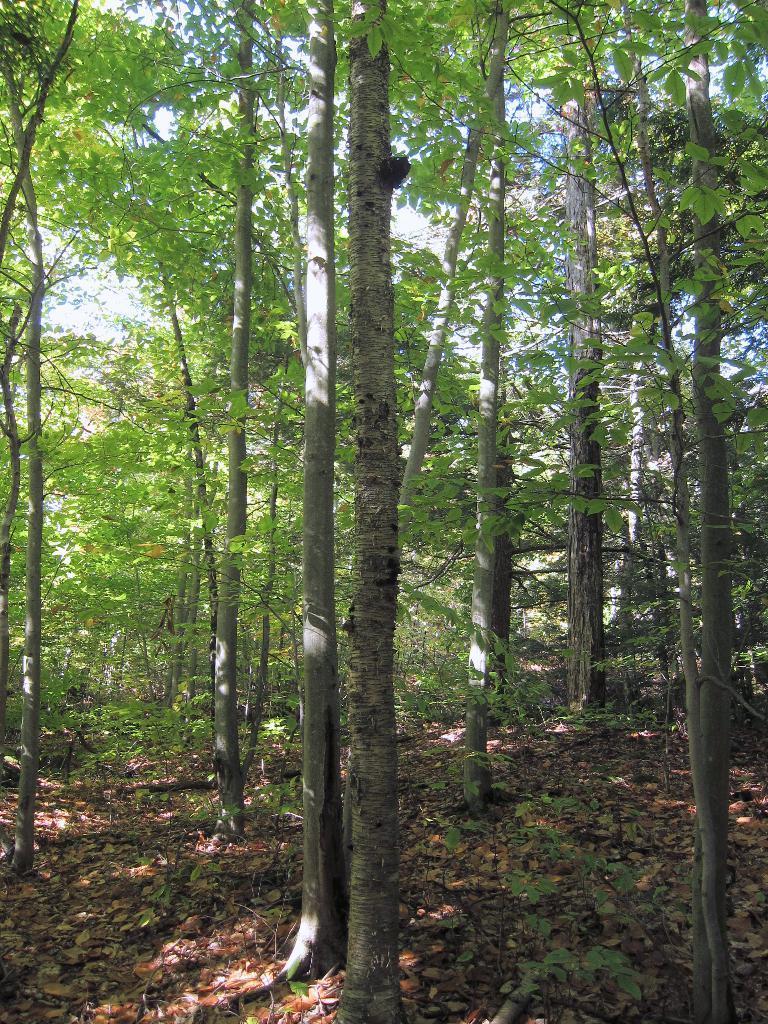Please provide a concise description of this image. In this image, we can see the ground with some dried leaves and plants. We can also see some trees and the sky. 